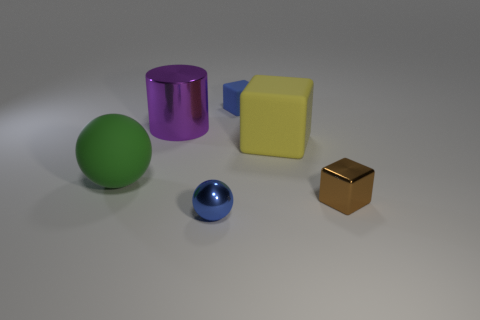Add 3 gray metal objects. How many objects exist? 9 Subtract all small cubes. How many cubes are left? 1 Subtract all green spheres. How many spheres are left? 1 Subtract 1 spheres. How many spheres are left? 1 Subtract all gray spheres. Subtract all yellow cylinders. How many spheres are left? 2 Add 6 red spheres. How many red spheres exist? 6 Subtract 0 red balls. How many objects are left? 6 Subtract all balls. How many objects are left? 4 Subtract all yellow cubes. How many red cylinders are left? 0 Subtract all small shiny cubes. Subtract all large yellow rubber things. How many objects are left? 4 